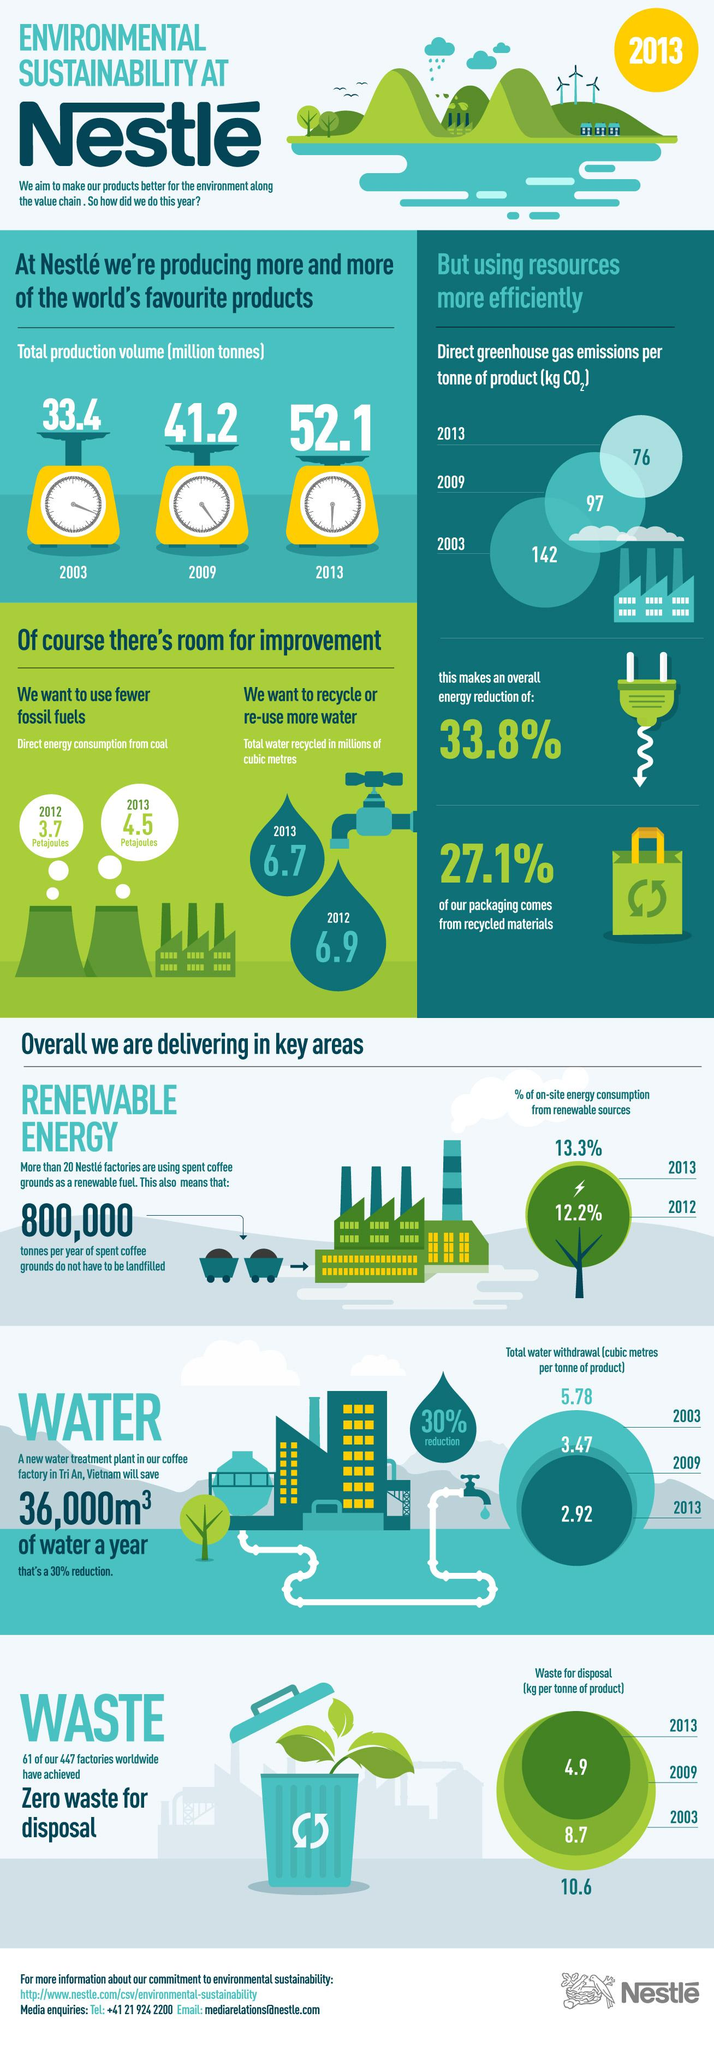Draw attention to some important aspects in this diagram. The total water withdrawal for Nestle products in 2013 was approximately 2.92 cubic meters per tonne. In 2012, Nestle's on-site energy consumption at its factories was partially sourced from renewable sources, with 12.2% coming from renewable energy sources. According to a recent study, 72.9% of Nestle's packaging materials are sourced from non-recycled materials. In 2009, the amount of waste generated for the disposal of each tonne of Nestle products was 8.7 kilograms. In 2012, Nestle factories recycled a total of 6.9 million cubic metres of water. 